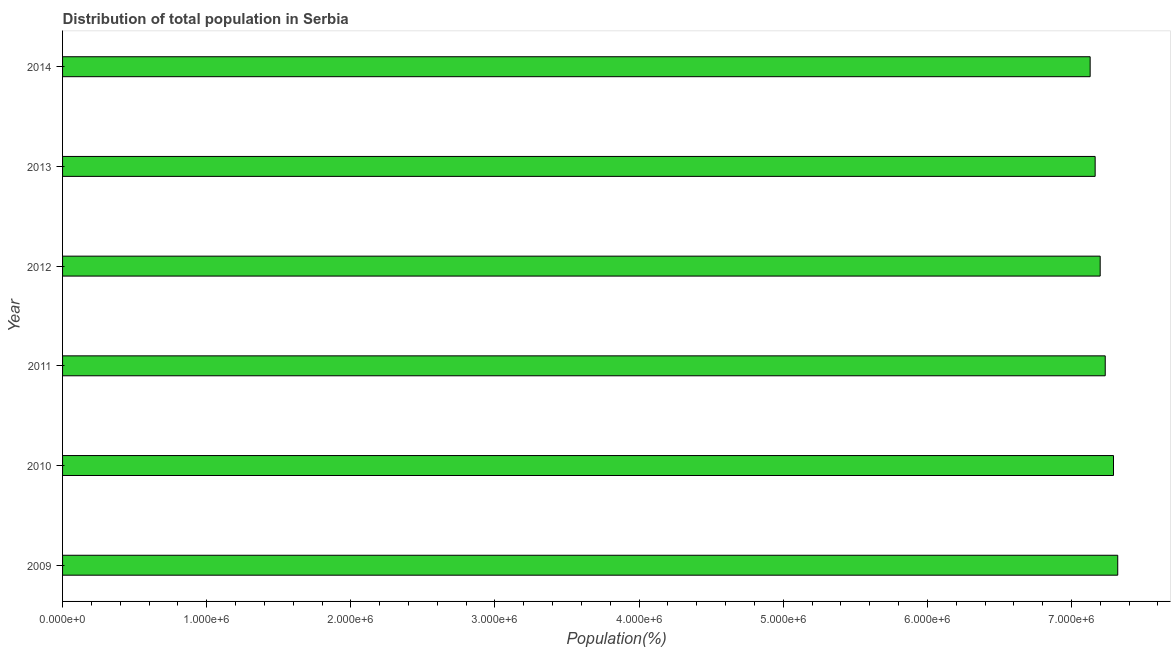Does the graph contain any zero values?
Make the answer very short. No. What is the title of the graph?
Offer a terse response. Distribution of total population in Serbia . What is the label or title of the X-axis?
Your answer should be compact. Population(%). What is the label or title of the Y-axis?
Make the answer very short. Year. What is the population in 2009?
Provide a short and direct response. 7.32e+06. Across all years, what is the maximum population?
Your response must be concise. 7.32e+06. Across all years, what is the minimum population?
Give a very brief answer. 7.13e+06. In which year was the population maximum?
Offer a terse response. 2009. In which year was the population minimum?
Your response must be concise. 2014. What is the sum of the population?
Offer a very short reply. 4.33e+07. What is the difference between the population in 2012 and 2013?
Give a very brief answer. 3.49e+04. What is the average population per year?
Provide a short and direct response. 7.22e+06. What is the median population?
Offer a very short reply. 7.22e+06. Do a majority of the years between 2009 and 2012 (inclusive) have population greater than 5600000 %?
Provide a short and direct response. Yes. Is the population in 2012 less than that in 2013?
Provide a succinct answer. No. Is the difference between the population in 2009 and 2012 greater than the difference between any two years?
Your answer should be very brief. No. What is the difference between the highest and the second highest population?
Your response must be concise. 2.94e+04. Is the sum of the population in 2009 and 2013 greater than the maximum population across all years?
Offer a very short reply. Yes. What is the difference between the highest and the lowest population?
Your answer should be very brief. 1.91e+05. In how many years, is the population greater than the average population taken over all years?
Offer a terse response. 3. What is the difference between two consecutive major ticks on the X-axis?
Make the answer very short. 1.00e+06. Are the values on the major ticks of X-axis written in scientific E-notation?
Offer a very short reply. Yes. What is the Population(%) in 2009?
Make the answer very short. 7.32e+06. What is the Population(%) of 2010?
Offer a very short reply. 7.29e+06. What is the Population(%) in 2011?
Your response must be concise. 7.23e+06. What is the Population(%) of 2012?
Your response must be concise. 7.20e+06. What is the Population(%) of 2013?
Make the answer very short. 7.16e+06. What is the Population(%) in 2014?
Your response must be concise. 7.13e+06. What is the difference between the Population(%) in 2009 and 2010?
Your response must be concise. 2.94e+04. What is the difference between the Population(%) in 2009 and 2011?
Give a very brief answer. 8.67e+04. What is the difference between the Population(%) in 2009 and 2012?
Provide a succinct answer. 1.22e+05. What is the difference between the Population(%) in 2009 and 2013?
Offer a terse response. 1.57e+05. What is the difference between the Population(%) in 2009 and 2014?
Ensure brevity in your answer.  1.91e+05. What is the difference between the Population(%) in 2010 and 2011?
Ensure brevity in your answer.  5.73e+04. What is the difference between the Population(%) in 2010 and 2012?
Provide a short and direct response. 9.24e+04. What is the difference between the Population(%) in 2010 and 2013?
Offer a terse response. 1.27e+05. What is the difference between the Population(%) in 2010 and 2014?
Your response must be concise. 1.62e+05. What is the difference between the Population(%) in 2011 and 2012?
Keep it short and to the point. 3.50e+04. What is the difference between the Population(%) in 2011 and 2013?
Make the answer very short. 7.00e+04. What is the difference between the Population(%) in 2011 and 2014?
Offer a terse response. 1.05e+05. What is the difference between the Population(%) in 2012 and 2013?
Offer a very short reply. 3.49e+04. What is the difference between the Population(%) in 2012 and 2014?
Your response must be concise. 6.96e+04. What is the difference between the Population(%) in 2013 and 2014?
Your response must be concise. 3.47e+04. What is the ratio of the Population(%) in 2009 to that in 2013?
Offer a very short reply. 1.02. What is the ratio of the Population(%) in 2010 to that in 2012?
Offer a very short reply. 1.01. What is the ratio of the Population(%) in 2010 to that in 2014?
Offer a very short reply. 1.02. What is the ratio of the Population(%) in 2011 to that in 2013?
Offer a terse response. 1.01. What is the ratio of the Population(%) in 2011 to that in 2014?
Offer a terse response. 1.01. What is the ratio of the Population(%) in 2012 to that in 2013?
Provide a short and direct response. 1. What is the ratio of the Population(%) in 2013 to that in 2014?
Make the answer very short. 1. 